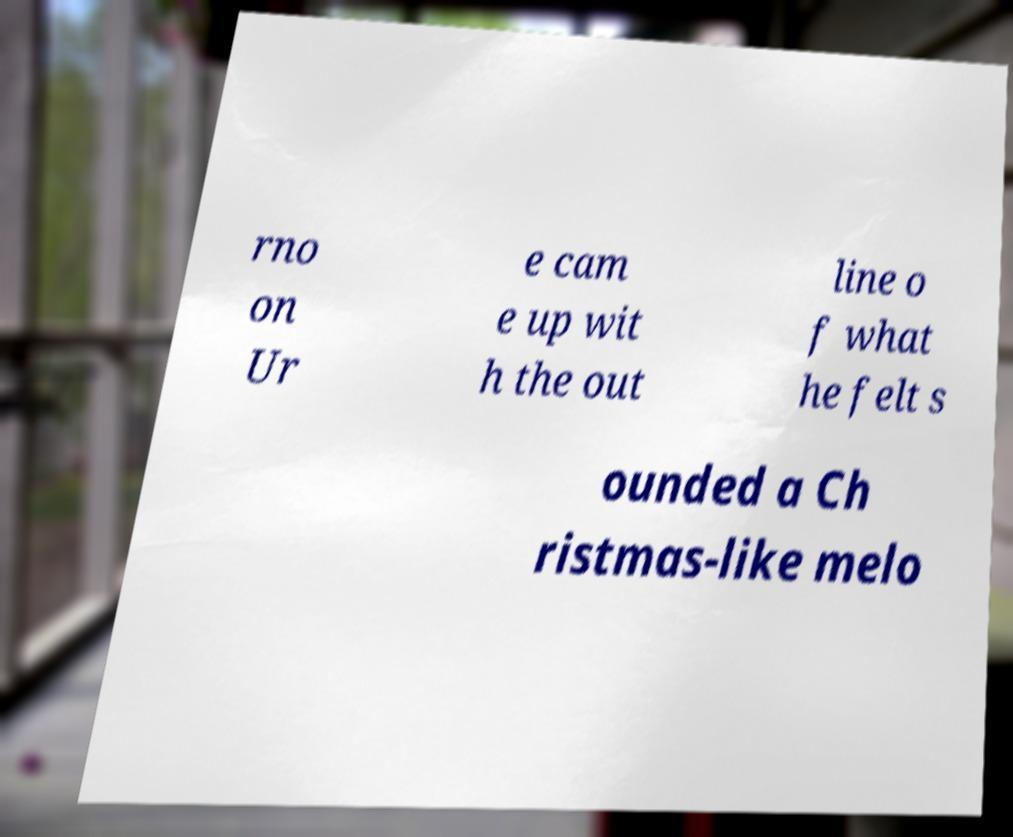Could you assist in decoding the text presented in this image and type it out clearly? rno on Ur e cam e up wit h the out line o f what he felt s ounded a Ch ristmas-like melo 